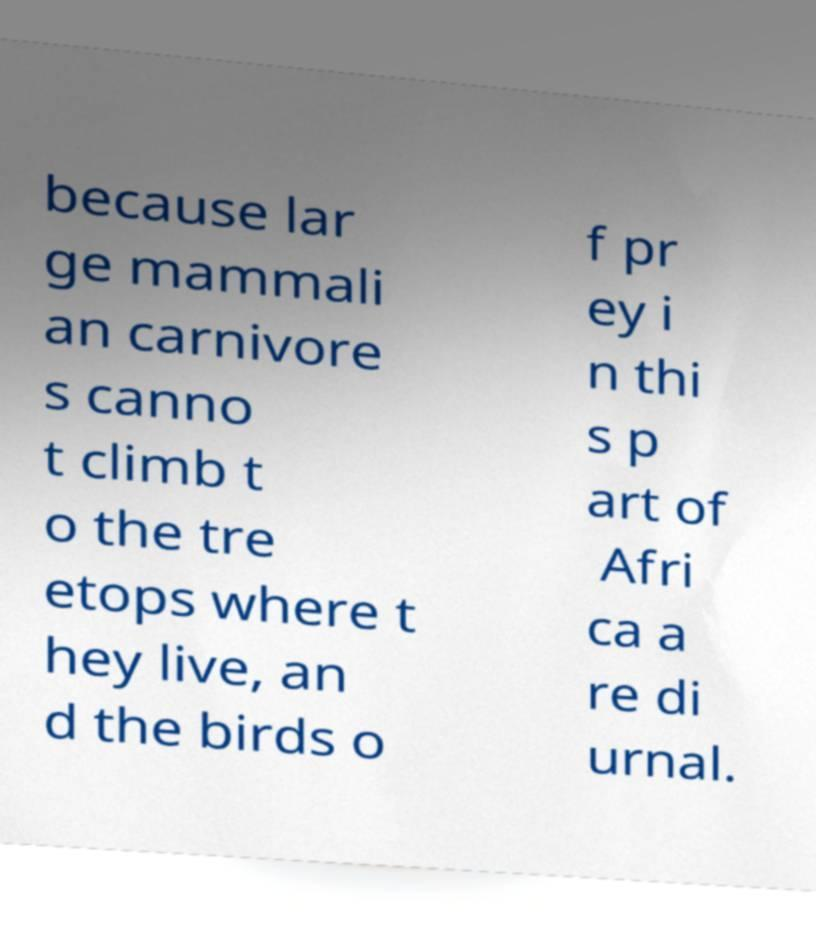I need the written content from this picture converted into text. Can you do that? because lar ge mammali an carnivore s canno t climb t o the tre etops where t hey live, an d the birds o f pr ey i n thi s p art of Afri ca a re di urnal. 